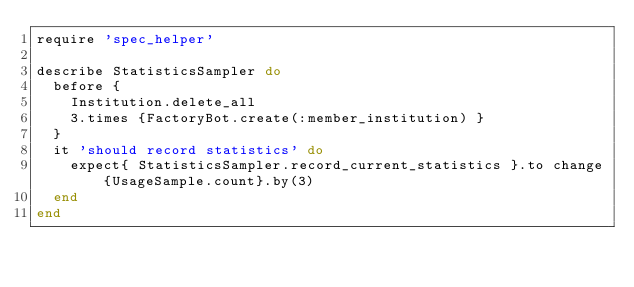Convert code to text. <code><loc_0><loc_0><loc_500><loc_500><_Ruby_>require 'spec_helper'

describe StatisticsSampler do
  before {
    Institution.delete_all
    3.times {FactoryBot.create(:member_institution) }
  }
  it 'should record statistics' do
    expect{ StatisticsSampler.record_current_statistics }.to change{UsageSample.count}.by(3)
  end
end</code> 